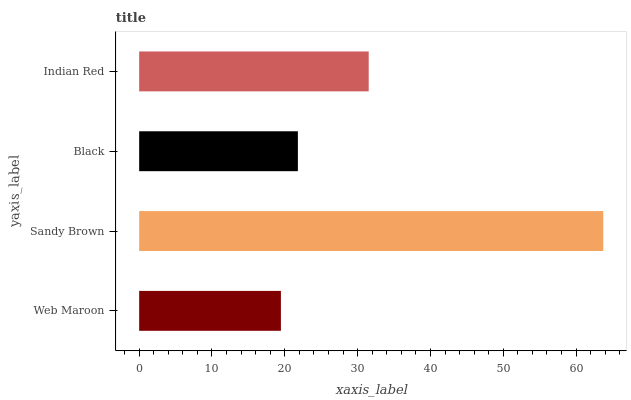Is Web Maroon the minimum?
Answer yes or no. Yes. Is Sandy Brown the maximum?
Answer yes or no. Yes. Is Black the minimum?
Answer yes or no. No. Is Black the maximum?
Answer yes or no. No. Is Sandy Brown greater than Black?
Answer yes or no. Yes. Is Black less than Sandy Brown?
Answer yes or no. Yes. Is Black greater than Sandy Brown?
Answer yes or no. No. Is Sandy Brown less than Black?
Answer yes or no. No. Is Indian Red the high median?
Answer yes or no. Yes. Is Black the low median?
Answer yes or no. Yes. Is Black the high median?
Answer yes or no. No. Is Web Maroon the low median?
Answer yes or no. No. 